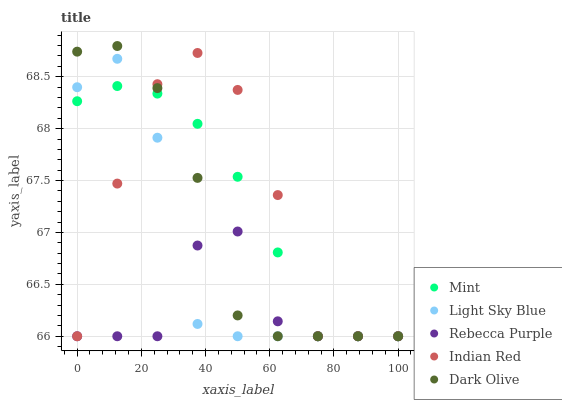Does Rebecca Purple have the minimum area under the curve?
Answer yes or no. Yes. Does Indian Red have the maximum area under the curve?
Answer yes or no. Yes. Does Light Sky Blue have the minimum area under the curve?
Answer yes or no. No. Does Light Sky Blue have the maximum area under the curve?
Answer yes or no. No. Is Mint the smoothest?
Answer yes or no. Yes. Is Indian Red the roughest?
Answer yes or no. Yes. Is Light Sky Blue the smoothest?
Answer yes or no. No. Is Light Sky Blue the roughest?
Answer yes or no. No. Does Dark Olive have the lowest value?
Answer yes or no. Yes. Does Dark Olive have the highest value?
Answer yes or no. Yes. Does Light Sky Blue have the highest value?
Answer yes or no. No. Does Dark Olive intersect Mint?
Answer yes or no. Yes. Is Dark Olive less than Mint?
Answer yes or no. No. Is Dark Olive greater than Mint?
Answer yes or no. No. 